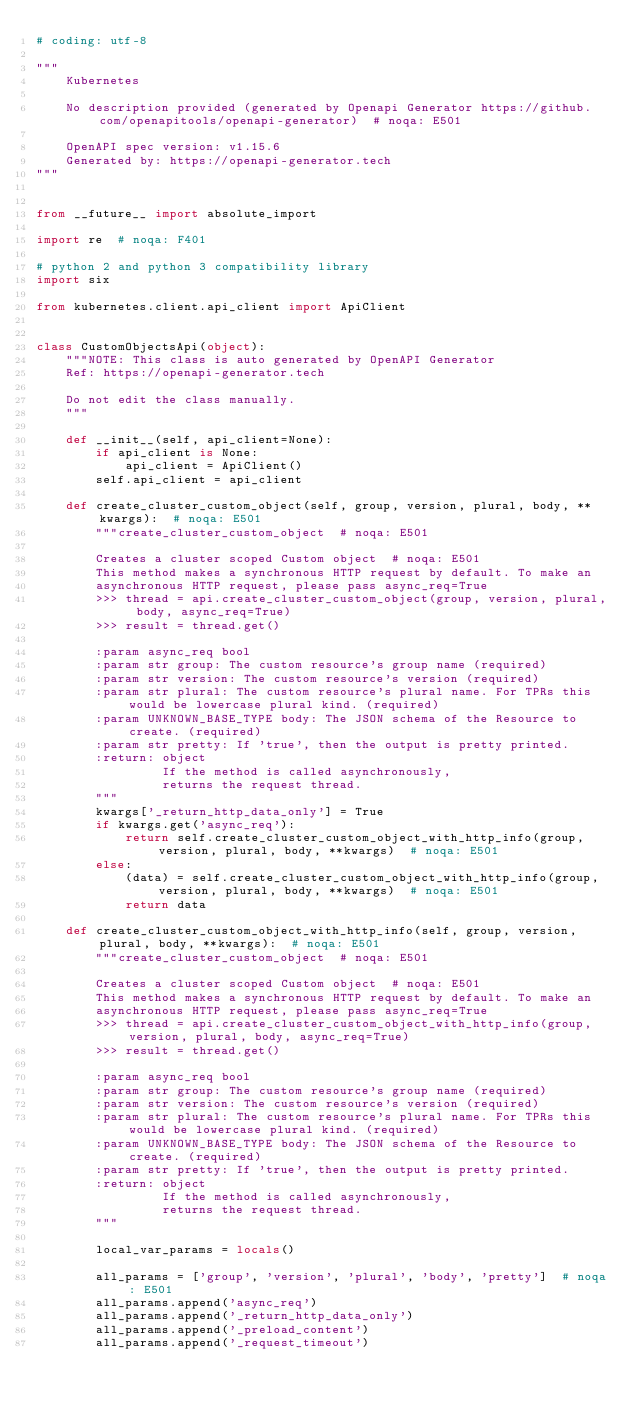Convert code to text. <code><loc_0><loc_0><loc_500><loc_500><_Python_># coding: utf-8

"""
    Kubernetes

    No description provided (generated by Openapi Generator https://github.com/openapitools/openapi-generator)  # noqa: E501

    OpenAPI spec version: v1.15.6
    Generated by: https://openapi-generator.tech
"""


from __future__ import absolute_import

import re  # noqa: F401

# python 2 and python 3 compatibility library
import six

from kubernetes.client.api_client import ApiClient


class CustomObjectsApi(object):
    """NOTE: This class is auto generated by OpenAPI Generator
    Ref: https://openapi-generator.tech

    Do not edit the class manually.
    """

    def __init__(self, api_client=None):
        if api_client is None:
            api_client = ApiClient()
        self.api_client = api_client

    def create_cluster_custom_object(self, group, version, plural, body, **kwargs):  # noqa: E501
        """create_cluster_custom_object  # noqa: E501

        Creates a cluster scoped Custom object  # noqa: E501
        This method makes a synchronous HTTP request by default. To make an
        asynchronous HTTP request, please pass async_req=True
        >>> thread = api.create_cluster_custom_object(group, version, plural, body, async_req=True)
        >>> result = thread.get()

        :param async_req bool
        :param str group: The custom resource's group name (required)
        :param str version: The custom resource's version (required)
        :param str plural: The custom resource's plural name. For TPRs this would be lowercase plural kind. (required)
        :param UNKNOWN_BASE_TYPE body: The JSON schema of the Resource to create. (required)
        :param str pretty: If 'true', then the output is pretty printed.
        :return: object
                 If the method is called asynchronously,
                 returns the request thread.
        """
        kwargs['_return_http_data_only'] = True
        if kwargs.get('async_req'):
            return self.create_cluster_custom_object_with_http_info(group, version, plural, body, **kwargs)  # noqa: E501
        else:
            (data) = self.create_cluster_custom_object_with_http_info(group, version, plural, body, **kwargs)  # noqa: E501
            return data

    def create_cluster_custom_object_with_http_info(self, group, version, plural, body, **kwargs):  # noqa: E501
        """create_cluster_custom_object  # noqa: E501

        Creates a cluster scoped Custom object  # noqa: E501
        This method makes a synchronous HTTP request by default. To make an
        asynchronous HTTP request, please pass async_req=True
        >>> thread = api.create_cluster_custom_object_with_http_info(group, version, plural, body, async_req=True)
        >>> result = thread.get()

        :param async_req bool
        :param str group: The custom resource's group name (required)
        :param str version: The custom resource's version (required)
        :param str plural: The custom resource's plural name. For TPRs this would be lowercase plural kind. (required)
        :param UNKNOWN_BASE_TYPE body: The JSON schema of the Resource to create. (required)
        :param str pretty: If 'true', then the output is pretty printed.
        :return: object
                 If the method is called asynchronously,
                 returns the request thread.
        """

        local_var_params = locals()

        all_params = ['group', 'version', 'plural', 'body', 'pretty']  # noqa: E501
        all_params.append('async_req')
        all_params.append('_return_http_data_only')
        all_params.append('_preload_content')
        all_params.append('_request_timeout')
</code> 